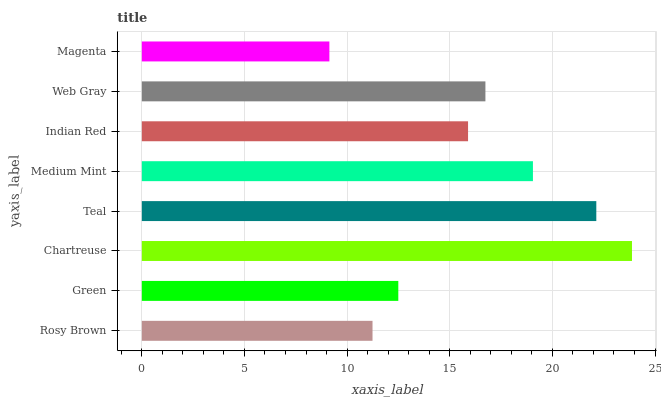Is Magenta the minimum?
Answer yes or no. Yes. Is Chartreuse the maximum?
Answer yes or no. Yes. Is Green the minimum?
Answer yes or no. No. Is Green the maximum?
Answer yes or no. No. Is Green greater than Rosy Brown?
Answer yes or no. Yes. Is Rosy Brown less than Green?
Answer yes or no. Yes. Is Rosy Brown greater than Green?
Answer yes or no. No. Is Green less than Rosy Brown?
Answer yes or no. No. Is Web Gray the high median?
Answer yes or no. Yes. Is Indian Red the low median?
Answer yes or no. Yes. Is Medium Mint the high median?
Answer yes or no. No. Is Web Gray the low median?
Answer yes or no. No. 